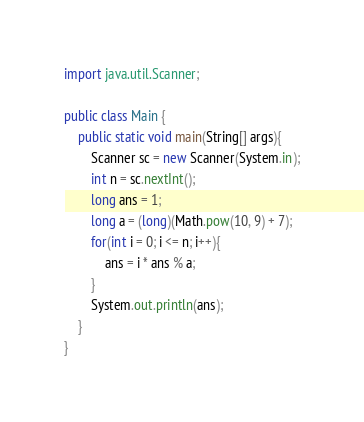<code> <loc_0><loc_0><loc_500><loc_500><_Java_>import java.util.Scanner;

public class Main {
	public static void main(String[] args){
		Scanner sc = new Scanner(System.in);
		int n = sc.nextInt();
		long ans = 1;
		long a = (long)(Math.pow(10, 9) + 7);
		for(int i = 0; i <= n; i++){
			ans = i * ans % a;
		}
		System.out.println(ans);
	}
}
</code> 